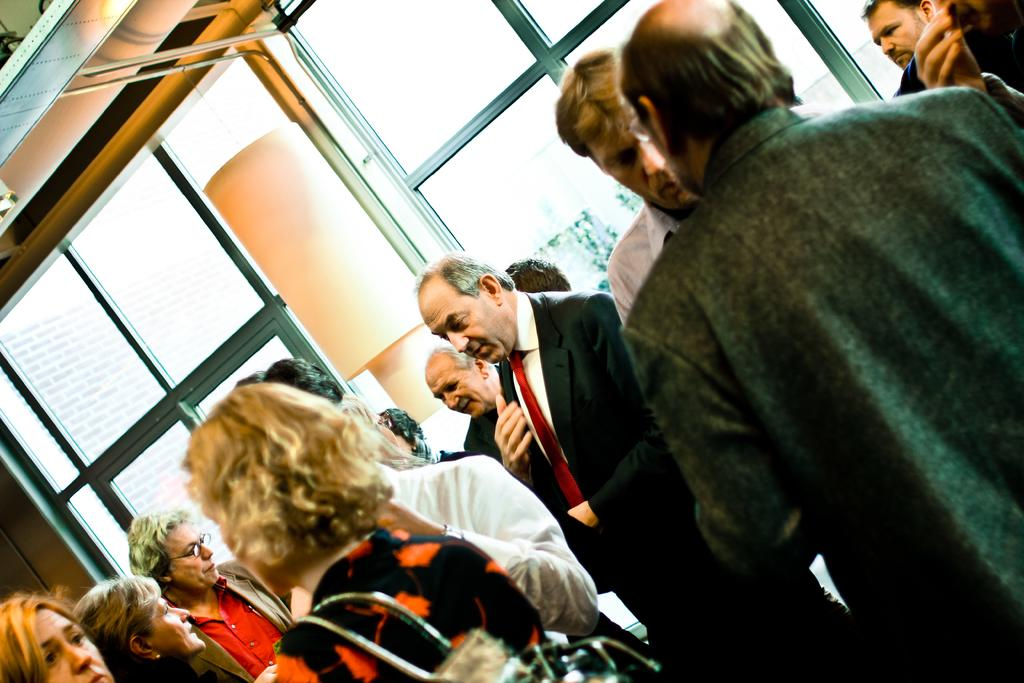What can be seen in the image? There are people standing in the image. What type of architectural feature can be seen in the background of the image? There are glass windows visible in the background of the image. What type of oven can be seen in the image? There is no oven present in the image. How many roses are visible in the image? There are no roses visible in the image. 